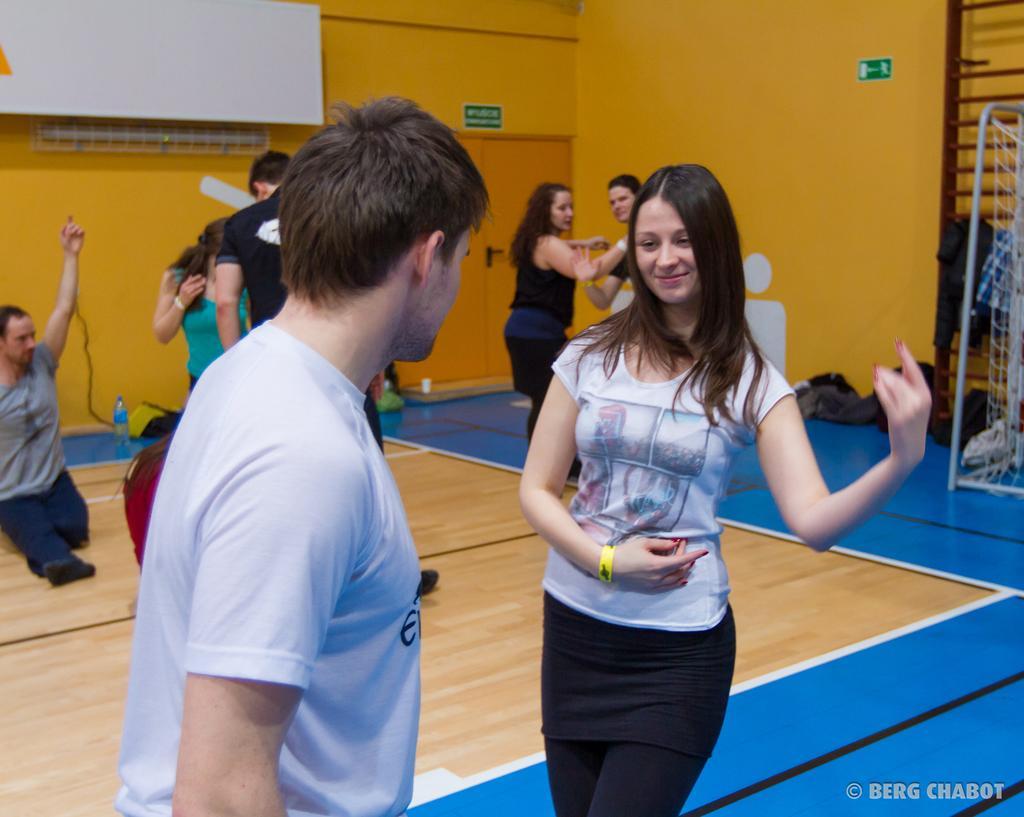In one or two sentences, can you explain what this image depicts? In front of the picture, we see the man and the women are standing. She is smiling. Behind them, we see four people are standing and they might be dancing. Beside them, we see the water bottle and a red bag. On the left side, we see a man in the grey T-shirt is sitting. On the right side, we see the net and a rack on which clothes are placed. Beside that, we see the clothes on the floor. At the bottom, we see a floor in blue color. In the background, we see a white board and a yellow wall. We even see the boards in green color with some text written on it. 